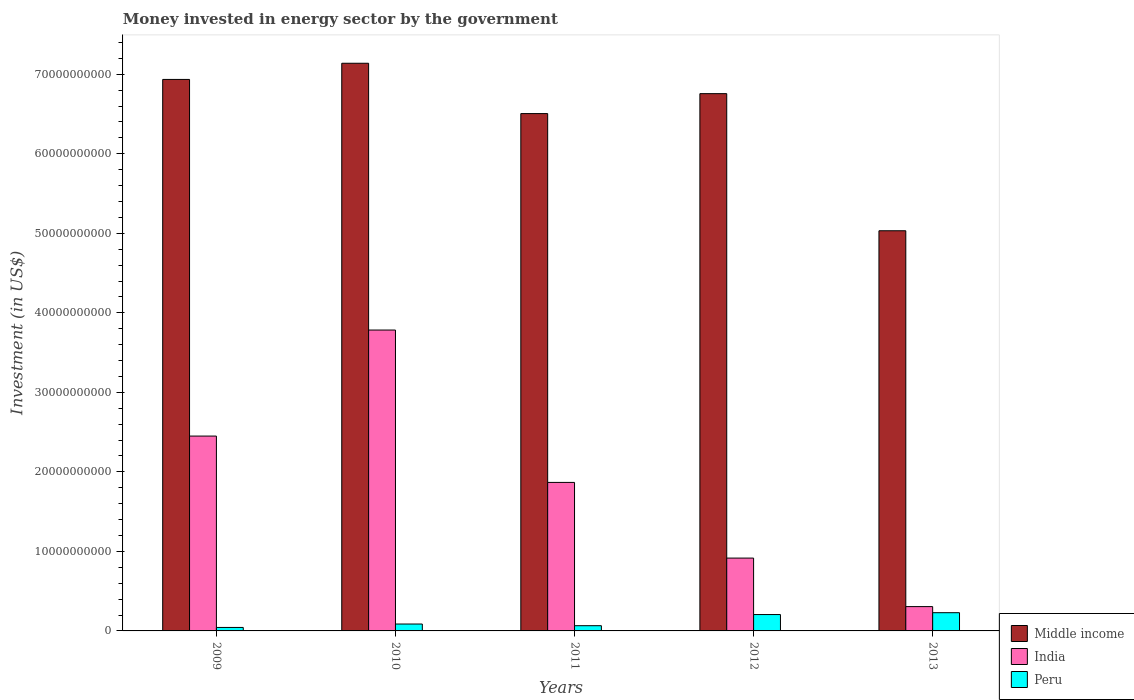How many groups of bars are there?
Make the answer very short. 5. Are the number of bars on each tick of the X-axis equal?
Your response must be concise. Yes. How many bars are there on the 1st tick from the left?
Provide a short and direct response. 3. How many bars are there on the 5th tick from the right?
Offer a very short reply. 3. In how many cases, is the number of bars for a given year not equal to the number of legend labels?
Give a very brief answer. 0. What is the money spent in energy sector in India in 2012?
Give a very brief answer. 9.16e+09. Across all years, what is the maximum money spent in energy sector in Peru?
Give a very brief answer. 2.29e+09. Across all years, what is the minimum money spent in energy sector in Peru?
Provide a succinct answer. 4.36e+08. In which year was the money spent in energy sector in Middle income maximum?
Your answer should be compact. 2010. In which year was the money spent in energy sector in Middle income minimum?
Provide a succinct answer. 2013. What is the total money spent in energy sector in India in the graph?
Ensure brevity in your answer.  9.32e+1. What is the difference between the money spent in energy sector in Middle income in 2010 and that in 2011?
Give a very brief answer. 6.33e+09. What is the difference between the money spent in energy sector in Peru in 2011 and the money spent in energy sector in India in 2012?
Your response must be concise. -8.50e+09. What is the average money spent in energy sector in Peru per year?
Ensure brevity in your answer.  1.26e+09. In the year 2011, what is the difference between the money spent in energy sector in India and money spent in energy sector in Peru?
Your answer should be compact. 1.80e+1. In how many years, is the money spent in energy sector in India greater than 20000000000 US$?
Your answer should be compact. 2. What is the ratio of the money spent in energy sector in India in 2009 to that in 2011?
Your response must be concise. 1.31. Is the difference between the money spent in energy sector in India in 2010 and 2012 greater than the difference between the money spent in energy sector in Peru in 2010 and 2012?
Your answer should be compact. Yes. What is the difference between the highest and the second highest money spent in energy sector in India?
Provide a succinct answer. 1.33e+1. What is the difference between the highest and the lowest money spent in energy sector in Peru?
Offer a terse response. 1.86e+09. Is the sum of the money spent in energy sector in Middle income in 2009 and 2011 greater than the maximum money spent in energy sector in Peru across all years?
Your answer should be compact. Yes. What does the 2nd bar from the left in 2011 represents?
Make the answer very short. India. Is it the case that in every year, the sum of the money spent in energy sector in Peru and money spent in energy sector in India is greater than the money spent in energy sector in Middle income?
Ensure brevity in your answer.  No. How many bars are there?
Your response must be concise. 15. How many years are there in the graph?
Ensure brevity in your answer.  5. What is the difference between two consecutive major ticks on the Y-axis?
Provide a succinct answer. 1.00e+1. Are the values on the major ticks of Y-axis written in scientific E-notation?
Your answer should be very brief. No. Does the graph contain grids?
Make the answer very short. No. Where does the legend appear in the graph?
Provide a succinct answer. Bottom right. How many legend labels are there?
Offer a terse response. 3. What is the title of the graph?
Make the answer very short. Money invested in energy sector by the government. What is the label or title of the X-axis?
Your answer should be compact. Years. What is the label or title of the Y-axis?
Provide a succinct answer. Investment (in US$). What is the Investment (in US$) of Middle income in 2009?
Keep it short and to the point. 6.94e+1. What is the Investment (in US$) of India in 2009?
Offer a terse response. 2.45e+1. What is the Investment (in US$) in Peru in 2009?
Offer a terse response. 4.36e+08. What is the Investment (in US$) of Middle income in 2010?
Your answer should be compact. 7.14e+1. What is the Investment (in US$) in India in 2010?
Ensure brevity in your answer.  3.78e+1. What is the Investment (in US$) in Peru in 2010?
Provide a short and direct response. 8.68e+08. What is the Investment (in US$) of Middle income in 2011?
Your response must be concise. 6.51e+1. What is the Investment (in US$) in India in 2011?
Provide a short and direct response. 1.87e+1. What is the Investment (in US$) in Peru in 2011?
Your response must be concise. 6.56e+08. What is the Investment (in US$) of Middle income in 2012?
Your answer should be very brief. 6.76e+1. What is the Investment (in US$) in India in 2012?
Your response must be concise. 9.16e+09. What is the Investment (in US$) in Peru in 2012?
Give a very brief answer. 2.06e+09. What is the Investment (in US$) in Middle income in 2013?
Your answer should be very brief. 5.03e+1. What is the Investment (in US$) in India in 2013?
Provide a succinct answer. 3.06e+09. What is the Investment (in US$) of Peru in 2013?
Offer a terse response. 2.29e+09. Across all years, what is the maximum Investment (in US$) of Middle income?
Keep it short and to the point. 7.14e+1. Across all years, what is the maximum Investment (in US$) of India?
Offer a very short reply. 3.78e+1. Across all years, what is the maximum Investment (in US$) of Peru?
Ensure brevity in your answer.  2.29e+09. Across all years, what is the minimum Investment (in US$) of Middle income?
Your response must be concise. 5.03e+1. Across all years, what is the minimum Investment (in US$) of India?
Make the answer very short. 3.06e+09. Across all years, what is the minimum Investment (in US$) in Peru?
Make the answer very short. 4.36e+08. What is the total Investment (in US$) in Middle income in the graph?
Provide a succinct answer. 3.24e+11. What is the total Investment (in US$) of India in the graph?
Your answer should be very brief. 9.32e+1. What is the total Investment (in US$) in Peru in the graph?
Keep it short and to the point. 6.31e+09. What is the difference between the Investment (in US$) of Middle income in 2009 and that in 2010?
Provide a short and direct response. -2.03e+09. What is the difference between the Investment (in US$) of India in 2009 and that in 2010?
Offer a very short reply. -1.33e+1. What is the difference between the Investment (in US$) in Peru in 2009 and that in 2010?
Ensure brevity in your answer.  -4.32e+08. What is the difference between the Investment (in US$) of Middle income in 2009 and that in 2011?
Offer a very short reply. 4.30e+09. What is the difference between the Investment (in US$) of India in 2009 and that in 2011?
Provide a succinct answer. 5.83e+09. What is the difference between the Investment (in US$) of Peru in 2009 and that in 2011?
Your response must be concise. -2.20e+08. What is the difference between the Investment (in US$) in Middle income in 2009 and that in 2012?
Ensure brevity in your answer.  1.79e+09. What is the difference between the Investment (in US$) in India in 2009 and that in 2012?
Your response must be concise. 1.53e+1. What is the difference between the Investment (in US$) in Peru in 2009 and that in 2012?
Your response must be concise. -1.62e+09. What is the difference between the Investment (in US$) of Middle income in 2009 and that in 2013?
Your response must be concise. 1.90e+1. What is the difference between the Investment (in US$) in India in 2009 and that in 2013?
Your response must be concise. 2.14e+1. What is the difference between the Investment (in US$) in Peru in 2009 and that in 2013?
Make the answer very short. -1.86e+09. What is the difference between the Investment (in US$) of Middle income in 2010 and that in 2011?
Your response must be concise. 6.33e+09. What is the difference between the Investment (in US$) of India in 2010 and that in 2011?
Give a very brief answer. 1.92e+1. What is the difference between the Investment (in US$) of Peru in 2010 and that in 2011?
Make the answer very short. 2.12e+08. What is the difference between the Investment (in US$) in Middle income in 2010 and that in 2012?
Offer a very short reply. 3.82e+09. What is the difference between the Investment (in US$) of India in 2010 and that in 2012?
Your response must be concise. 2.87e+1. What is the difference between the Investment (in US$) of Peru in 2010 and that in 2012?
Ensure brevity in your answer.  -1.19e+09. What is the difference between the Investment (in US$) of Middle income in 2010 and that in 2013?
Make the answer very short. 2.11e+1. What is the difference between the Investment (in US$) of India in 2010 and that in 2013?
Ensure brevity in your answer.  3.48e+1. What is the difference between the Investment (in US$) in Peru in 2010 and that in 2013?
Provide a short and direct response. -1.42e+09. What is the difference between the Investment (in US$) in Middle income in 2011 and that in 2012?
Your answer should be very brief. -2.51e+09. What is the difference between the Investment (in US$) in India in 2011 and that in 2012?
Ensure brevity in your answer.  9.52e+09. What is the difference between the Investment (in US$) in Peru in 2011 and that in 2012?
Offer a terse response. -1.40e+09. What is the difference between the Investment (in US$) in Middle income in 2011 and that in 2013?
Your answer should be very brief. 1.47e+1. What is the difference between the Investment (in US$) in India in 2011 and that in 2013?
Make the answer very short. 1.56e+1. What is the difference between the Investment (in US$) in Peru in 2011 and that in 2013?
Ensure brevity in your answer.  -1.64e+09. What is the difference between the Investment (in US$) of Middle income in 2012 and that in 2013?
Offer a very short reply. 1.72e+1. What is the difference between the Investment (in US$) in India in 2012 and that in 2013?
Give a very brief answer. 6.10e+09. What is the difference between the Investment (in US$) of Peru in 2012 and that in 2013?
Provide a succinct answer. -2.34e+08. What is the difference between the Investment (in US$) in Middle income in 2009 and the Investment (in US$) in India in 2010?
Offer a terse response. 3.15e+1. What is the difference between the Investment (in US$) in Middle income in 2009 and the Investment (in US$) in Peru in 2010?
Ensure brevity in your answer.  6.85e+1. What is the difference between the Investment (in US$) of India in 2009 and the Investment (in US$) of Peru in 2010?
Ensure brevity in your answer.  2.36e+1. What is the difference between the Investment (in US$) in Middle income in 2009 and the Investment (in US$) in India in 2011?
Make the answer very short. 5.07e+1. What is the difference between the Investment (in US$) in Middle income in 2009 and the Investment (in US$) in Peru in 2011?
Make the answer very short. 6.87e+1. What is the difference between the Investment (in US$) of India in 2009 and the Investment (in US$) of Peru in 2011?
Your answer should be compact. 2.38e+1. What is the difference between the Investment (in US$) of Middle income in 2009 and the Investment (in US$) of India in 2012?
Keep it short and to the point. 6.02e+1. What is the difference between the Investment (in US$) in Middle income in 2009 and the Investment (in US$) in Peru in 2012?
Make the answer very short. 6.73e+1. What is the difference between the Investment (in US$) of India in 2009 and the Investment (in US$) of Peru in 2012?
Make the answer very short. 2.24e+1. What is the difference between the Investment (in US$) in Middle income in 2009 and the Investment (in US$) in India in 2013?
Provide a succinct answer. 6.63e+1. What is the difference between the Investment (in US$) of Middle income in 2009 and the Investment (in US$) of Peru in 2013?
Offer a very short reply. 6.71e+1. What is the difference between the Investment (in US$) of India in 2009 and the Investment (in US$) of Peru in 2013?
Your answer should be very brief. 2.22e+1. What is the difference between the Investment (in US$) of Middle income in 2010 and the Investment (in US$) of India in 2011?
Offer a very short reply. 5.27e+1. What is the difference between the Investment (in US$) in Middle income in 2010 and the Investment (in US$) in Peru in 2011?
Your response must be concise. 7.07e+1. What is the difference between the Investment (in US$) in India in 2010 and the Investment (in US$) in Peru in 2011?
Make the answer very short. 3.72e+1. What is the difference between the Investment (in US$) of Middle income in 2010 and the Investment (in US$) of India in 2012?
Your response must be concise. 6.22e+1. What is the difference between the Investment (in US$) of Middle income in 2010 and the Investment (in US$) of Peru in 2012?
Keep it short and to the point. 6.93e+1. What is the difference between the Investment (in US$) in India in 2010 and the Investment (in US$) in Peru in 2012?
Ensure brevity in your answer.  3.58e+1. What is the difference between the Investment (in US$) in Middle income in 2010 and the Investment (in US$) in India in 2013?
Provide a short and direct response. 6.83e+1. What is the difference between the Investment (in US$) of Middle income in 2010 and the Investment (in US$) of Peru in 2013?
Your response must be concise. 6.91e+1. What is the difference between the Investment (in US$) of India in 2010 and the Investment (in US$) of Peru in 2013?
Offer a very short reply. 3.55e+1. What is the difference between the Investment (in US$) in Middle income in 2011 and the Investment (in US$) in India in 2012?
Ensure brevity in your answer.  5.59e+1. What is the difference between the Investment (in US$) of Middle income in 2011 and the Investment (in US$) of Peru in 2012?
Ensure brevity in your answer.  6.30e+1. What is the difference between the Investment (in US$) in India in 2011 and the Investment (in US$) in Peru in 2012?
Offer a very short reply. 1.66e+1. What is the difference between the Investment (in US$) in Middle income in 2011 and the Investment (in US$) in India in 2013?
Make the answer very short. 6.20e+1. What is the difference between the Investment (in US$) in Middle income in 2011 and the Investment (in US$) in Peru in 2013?
Your answer should be compact. 6.28e+1. What is the difference between the Investment (in US$) of India in 2011 and the Investment (in US$) of Peru in 2013?
Offer a very short reply. 1.64e+1. What is the difference between the Investment (in US$) in Middle income in 2012 and the Investment (in US$) in India in 2013?
Your answer should be very brief. 6.45e+1. What is the difference between the Investment (in US$) in Middle income in 2012 and the Investment (in US$) in Peru in 2013?
Ensure brevity in your answer.  6.53e+1. What is the difference between the Investment (in US$) of India in 2012 and the Investment (in US$) of Peru in 2013?
Provide a short and direct response. 6.87e+09. What is the average Investment (in US$) of Middle income per year?
Your answer should be compact. 6.47e+1. What is the average Investment (in US$) of India per year?
Your response must be concise. 1.86e+1. What is the average Investment (in US$) in Peru per year?
Offer a very short reply. 1.26e+09. In the year 2009, what is the difference between the Investment (in US$) in Middle income and Investment (in US$) in India?
Give a very brief answer. 4.48e+1. In the year 2009, what is the difference between the Investment (in US$) in Middle income and Investment (in US$) in Peru?
Your answer should be compact. 6.89e+1. In the year 2009, what is the difference between the Investment (in US$) of India and Investment (in US$) of Peru?
Provide a short and direct response. 2.41e+1. In the year 2010, what is the difference between the Investment (in US$) of Middle income and Investment (in US$) of India?
Provide a succinct answer. 3.35e+1. In the year 2010, what is the difference between the Investment (in US$) in Middle income and Investment (in US$) in Peru?
Your answer should be compact. 7.05e+1. In the year 2010, what is the difference between the Investment (in US$) of India and Investment (in US$) of Peru?
Your answer should be compact. 3.70e+1. In the year 2011, what is the difference between the Investment (in US$) in Middle income and Investment (in US$) in India?
Provide a succinct answer. 4.64e+1. In the year 2011, what is the difference between the Investment (in US$) in Middle income and Investment (in US$) in Peru?
Make the answer very short. 6.44e+1. In the year 2011, what is the difference between the Investment (in US$) in India and Investment (in US$) in Peru?
Keep it short and to the point. 1.80e+1. In the year 2012, what is the difference between the Investment (in US$) in Middle income and Investment (in US$) in India?
Provide a succinct answer. 5.84e+1. In the year 2012, what is the difference between the Investment (in US$) of Middle income and Investment (in US$) of Peru?
Offer a terse response. 6.55e+1. In the year 2012, what is the difference between the Investment (in US$) of India and Investment (in US$) of Peru?
Keep it short and to the point. 7.10e+09. In the year 2013, what is the difference between the Investment (in US$) in Middle income and Investment (in US$) in India?
Make the answer very short. 4.73e+1. In the year 2013, what is the difference between the Investment (in US$) of Middle income and Investment (in US$) of Peru?
Ensure brevity in your answer.  4.80e+1. In the year 2013, what is the difference between the Investment (in US$) in India and Investment (in US$) in Peru?
Your response must be concise. 7.66e+08. What is the ratio of the Investment (in US$) in Middle income in 2009 to that in 2010?
Make the answer very short. 0.97. What is the ratio of the Investment (in US$) of India in 2009 to that in 2010?
Make the answer very short. 0.65. What is the ratio of the Investment (in US$) in Peru in 2009 to that in 2010?
Provide a short and direct response. 0.5. What is the ratio of the Investment (in US$) of Middle income in 2009 to that in 2011?
Provide a short and direct response. 1.07. What is the ratio of the Investment (in US$) of India in 2009 to that in 2011?
Offer a very short reply. 1.31. What is the ratio of the Investment (in US$) in Peru in 2009 to that in 2011?
Make the answer very short. 0.66. What is the ratio of the Investment (in US$) of Middle income in 2009 to that in 2012?
Your answer should be very brief. 1.03. What is the ratio of the Investment (in US$) in India in 2009 to that in 2012?
Ensure brevity in your answer.  2.68. What is the ratio of the Investment (in US$) of Peru in 2009 to that in 2012?
Offer a very short reply. 0.21. What is the ratio of the Investment (in US$) in Middle income in 2009 to that in 2013?
Your answer should be compact. 1.38. What is the ratio of the Investment (in US$) of India in 2009 to that in 2013?
Your response must be concise. 8.01. What is the ratio of the Investment (in US$) of Peru in 2009 to that in 2013?
Ensure brevity in your answer.  0.19. What is the ratio of the Investment (in US$) in Middle income in 2010 to that in 2011?
Provide a succinct answer. 1.1. What is the ratio of the Investment (in US$) of India in 2010 to that in 2011?
Make the answer very short. 2.03. What is the ratio of the Investment (in US$) in Peru in 2010 to that in 2011?
Provide a short and direct response. 1.32. What is the ratio of the Investment (in US$) in Middle income in 2010 to that in 2012?
Offer a very short reply. 1.06. What is the ratio of the Investment (in US$) in India in 2010 to that in 2012?
Offer a very short reply. 4.13. What is the ratio of the Investment (in US$) in Peru in 2010 to that in 2012?
Give a very brief answer. 0.42. What is the ratio of the Investment (in US$) in Middle income in 2010 to that in 2013?
Provide a short and direct response. 1.42. What is the ratio of the Investment (in US$) in India in 2010 to that in 2013?
Give a very brief answer. 12.37. What is the ratio of the Investment (in US$) of Peru in 2010 to that in 2013?
Keep it short and to the point. 0.38. What is the ratio of the Investment (in US$) in Middle income in 2011 to that in 2012?
Ensure brevity in your answer.  0.96. What is the ratio of the Investment (in US$) of India in 2011 to that in 2012?
Your answer should be compact. 2.04. What is the ratio of the Investment (in US$) of Peru in 2011 to that in 2012?
Offer a terse response. 0.32. What is the ratio of the Investment (in US$) in Middle income in 2011 to that in 2013?
Provide a succinct answer. 1.29. What is the ratio of the Investment (in US$) of India in 2011 to that in 2013?
Keep it short and to the point. 6.11. What is the ratio of the Investment (in US$) of Peru in 2011 to that in 2013?
Ensure brevity in your answer.  0.29. What is the ratio of the Investment (in US$) in Middle income in 2012 to that in 2013?
Make the answer very short. 1.34. What is the ratio of the Investment (in US$) of India in 2012 to that in 2013?
Make the answer very short. 3. What is the ratio of the Investment (in US$) in Peru in 2012 to that in 2013?
Ensure brevity in your answer.  0.9. What is the difference between the highest and the second highest Investment (in US$) of Middle income?
Your answer should be compact. 2.03e+09. What is the difference between the highest and the second highest Investment (in US$) of India?
Provide a short and direct response. 1.33e+1. What is the difference between the highest and the second highest Investment (in US$) in Peru?
Your response must be concise. 2.34e+08. What is the difference between the highest and the lowest Investment (in US$) of Middle income?
Give a very brief answer. 2.11e+1. What is the difference between the highest and the lowest Investment (in US$) of India?
Make the answer very short. 3.48e+1. What is the difference between the highest and the lowest Investment (in US$) in Peru?
Offer a very short reply. 1.86e+09. 